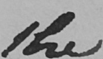Can you tell me what this handwritten text says? the 